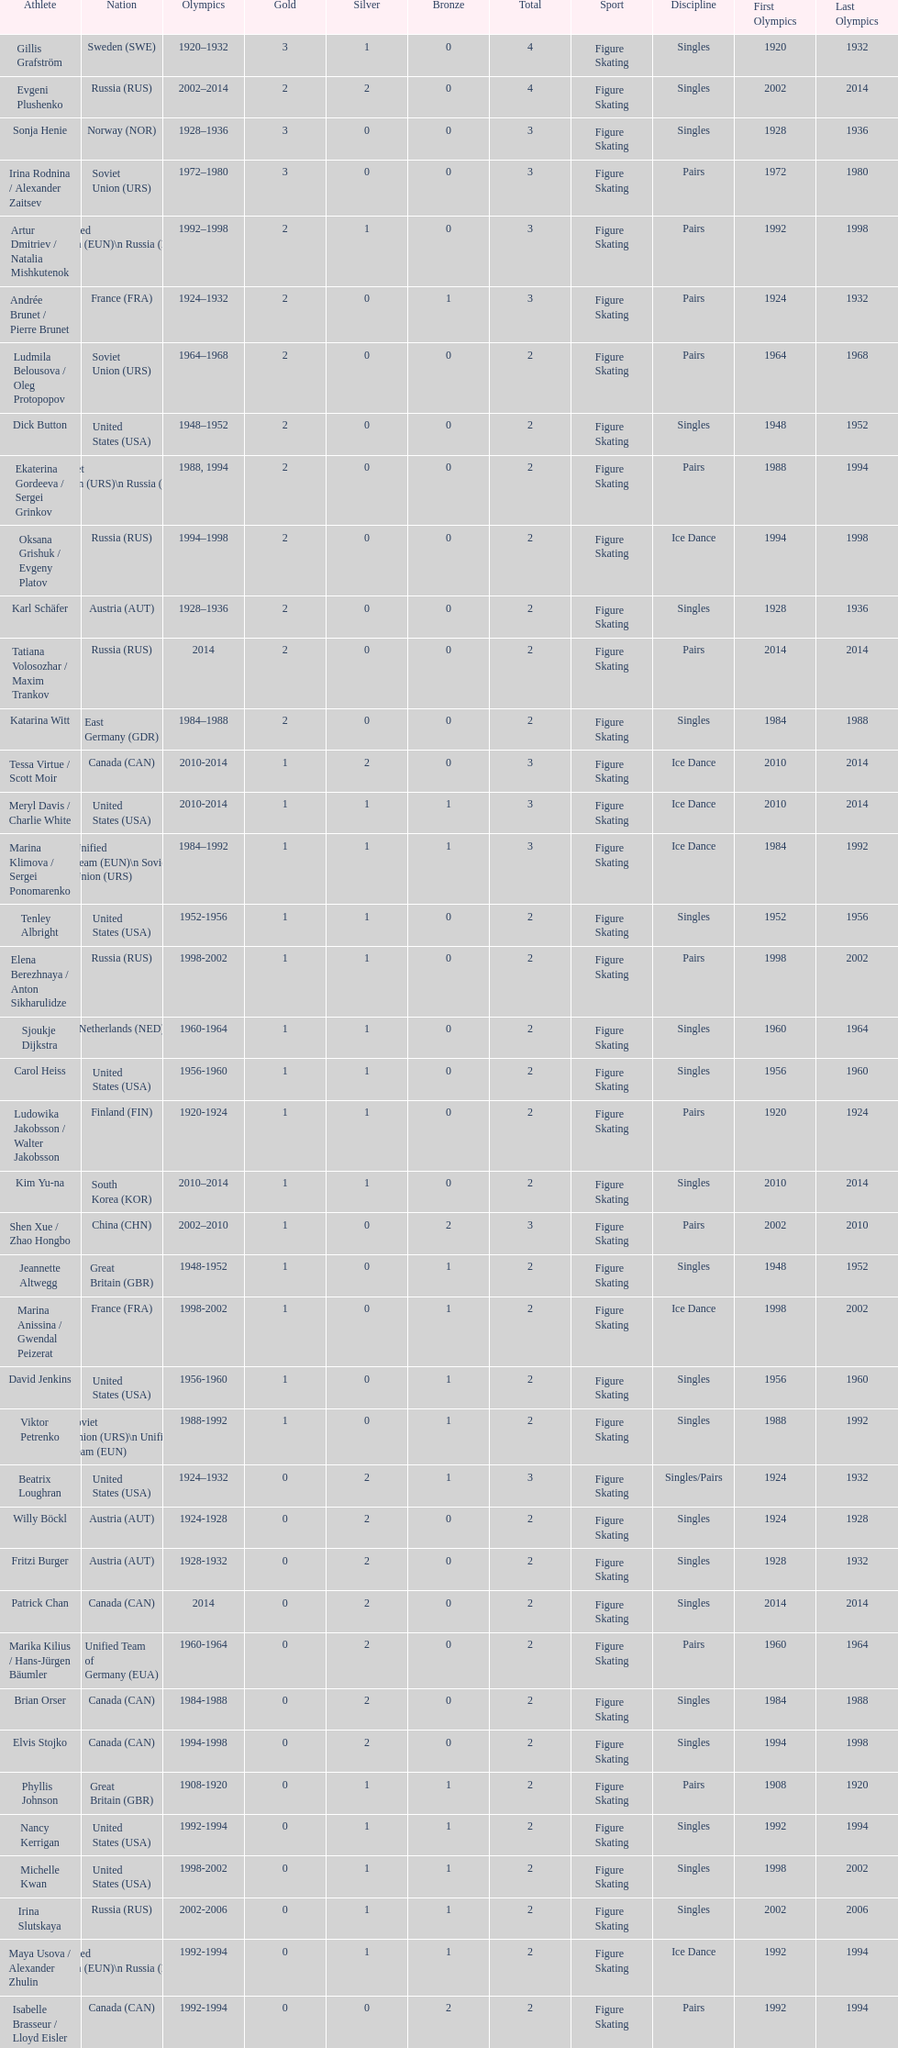Write the full table. {'header': ['Athlete', 'Nation', 'Olympics', 'Gold', 'Silver', 'Bronze', 'Total', 'Sport', 'Discipline', 'First Olympics', 'Last Olympics'], 'rows': [['Gillis Grafström', 'Sweden\xa0(SWE)', '1920–1932', '3', '1', '0', '4', 'Figure Skating', 'Singles', '1920', '1932'], ['Evgeni Plushenko', 'Russia\xa0(RUS)', '2002–2014', '2', '2', '0', '4', 'Figure Skating', 'Singles', '2002', '2014'], ['Sonja Henie', 'Norway\xa0(NOR)', '1928–1936', '3', '0', '0', '3', 'Figure Skating', 'Singles', '1928', '1936'], ['Irina Rodnina / Alexander Zaitsev', 'Soviet Union\xa0(URS)', '1972–1980', '3', '0', '0', '3', 'Figure Skating', 'Pairs', '1972', '1980'], ['Artur Dmitriev / Natalia Mishkutenok', 'Unified Team\xa0(EUN)\\n\xa0Russia\xa0(RUS)', '1992–1998', '2', '1', '0', '3', 'Figure Skating', 'Pairs', '1992', '1998'], ['Andrée Brunet / Pierre Brunet', 'France\xa0(FRA)', '1924–1932', '2', '0', '1', '3', 'Figure Skating', 'Pairs', '1924', '1932'], ['Ludmila Belousova / Oleg Protopopov', 'Soviet Union\xa0(URS)', '1964–1968', '2', '0', '0', '2', 'Figure Skating', 'Pairs', '1964', '1968'], ['Dick Button', 'United States\xa0(USA)', '1948–1952', '2', '0', '0', '2', 'Figure Skating', 'Singles', '1948', '1952'], ['Ekaterina Gordeeva / Sergei Grinkov', 'Soviet Union\xa0(URS)\\n\xa0Russia\xa0(RUS)', '1988, 1994', '2', '0', '0', '2', 'Figure Skating', 'Pairs', '1988', '1994'], ['Oksana Grishuk / Evgeny Platov', 'Russia\xa0(RUS)', '1994–1998', '2', '0', '0', '2', 'Figure Skating', 'Ice Dance', '1994', '1998'], ['Karl Schäfer', 'Austria\xa0(AUT)', '1928–1936', '2', '0', '0', '2', 'Figure Skating', 'Singles', '1928', '1936'], ['Tatiana Volosozhar / Maxim Trankov', 'Russia\xa0(RUS)', '2014', '2', '0', '0', '2', 'Figure Skating', 'Pairs', '2014', '2014'], ['Katarina Witt', 'East Germany\xa0(GDR)', '1984–1988', '2', '0', '0', '2', 'Figure Skating', 'Singles', '1984', '1988'], ['Tessa Virtue / Scott Moir', 'Canada\xa0(CAN)', '2010-2014', '1', '2', '0', '3', 'Figure Skating', 'Ice Dance', '2010', '2014'], ['Meryl Davis / Charlie White', 'United States\xa0(USA)', '2010-2014', '1', '1', '1', '3', 'Figure Skating', 'Ice Dance', '2010', '2014'], ['Marina Klimova / Sergei Ponomarenko', 'Unified Team\xa0(EUN)\\n\xa0Soviet Union\xa0(URS)', '1984–1992', '1', '1', '1', '3', 'Figure Skating', 'Ice Dance', '1984', '1992'], ['Tenley Albright', 'United States\xa0(USA)', '1952-1956', '1', '1', '0', '2', 'Figure Skating', 'Singles', '1952', '1956'], ['Elena Berezhnaya / Anton Sikharulidze', 'Russia\xa0(RUS)', '1998-2002', '1', '1', '0', '2', 'Figure Skating', 'Pairs', '1998', '2002'], ['Sjoukje Dijkstra', 'Netherlands\xa0(NED)', '1960-1964', '1', '1', '0', '2', 'Figure Skating', 'Singles', '1960', '1964'], ['Carol Heiss', 'United States\xa0(USA)', '1956-1960', '1', '1', '0', '2', 'Figure Skating', 'Singles', '1956', '1960'], ['Ludowika Jakobsson / Walter Jakobsson', 'Finland\xa0(FIN)', '1920-1924', '1', '1', '0', '2', 'Figure Skating', 'Pairs', '1920', '1924'], ['Kim Yu-na', 'South Korea\xa0(KOR)', '2010–2014', '1', '1', '0', '2', 'Figure Skating', 'Singles', '2010', '2014'], ['Shen Xue / Zhao Hongbo', 'China\xa0(CHN)', '2002–2010', '1', '0', '2', '3', 'Figure Skating', 'Pairs', '2002', '2010'], ['Jeannette Altwegg', 'Great Britain\xa0(GBR)', '1948-1952', '1', '0', '1', '2', 'Figure Skating', 'Singles', '1948', '1952'], ['Marina Anissina / Gwendal Peizerat', 'France\xa0(FRA)', '1998-2002', '1', '0', '1', '2', 'Figure Skating', 'Ice Dance', '1998', '2002'], ['David Jenkins', 'United States\xa0(USA)', '1956-1960', '1', '0', '1', '2', 'Figure Skating', 'Singles', '1956', '1960'], ['Viktor Petrenko', 'Soviet Union\xa0(URS)\\n\xa0Unified Team\xa0(EUN)', '1988-1992', '1', '0', '1', '2', 'Figure Skating', 'Singles', '1988', '1992'], ['Beatrix Loughran', 'United States\xa0(USA)', '1924–1932', '0', '2', '1', '3', 'Figure Skating', 'Singles/Pairs', '1924', '1932'], ['Willy Böckl', 'Austria\xa0(AUT)', '1924-1928', '0', '2', '0', '2', 'Figure Skating', 'Singles', '1924', '1928'], ['Fritzi Burger', 'Austria\xa0(AUT)', '1928-1932', '0', '2', '0', '2', 'Figure Skating', 'Singles', '1928', '1932'], ['Patrick Chan', 'Canada\xa0(CAN)', '2014', '0', '2', '0', '2', 'Figure Skating', 'Singles', '2014', '2014'], ['Marika Kilius / Hans-Jürgen Bäumler', 'Unified Team of Germany\xa0(EUA)', '1960-1964', '0', '2', '0', '2', 'Figure Skating', 'Pairs', '1960', '1964'], ['Brian Orser', 'Canada\xa0(CAN)', '1984-1988', '0', '2', '0', '2', 'Figure Skating', 'Singles', '1984', '1988'], ['Elvis Stojko', 'Canada\xa0(CAN)', '1994-1998', '0', '2', '0', '2', 'Figure Skating', 'Singles', '1994', '1998'], ['Phyllis Johnson', 'Great Britain\xa0(GBR)', '1908-1920', '0', '1', '1', '2', 'Figure Skating', 'Pairs', '1908', '1920'], ['Nancy Kerrigan', 'United States\xa0(USA)', '1992-1994', '0', '1', '1', '2', 'Figure Skating', 'Singles', '1992', '1994'], ['Michelle Kwan', 'United States\xa0(USA)', '1998-2002', '0', '1', '1', '2', 'Figure Skating', 'Singles', '1998', '2002'], ['Irina Slutskaya', 'Russia\xa0(RUS)', '2002-2006', '0', '1', '1', '2', 'Figure Skating', 'Singles', '2002', '2006'], ['Maya Usova / Alexander Zhulin', 'Unified Team\xa0(EUN)\\n\xa0Russia\xa0(RUS)', '1992-1994', '0', '1', '1', '2', 'Figure Skating', 'Ice Dance', '1992', '1994'], ['Isabelle Brasseur / Lloyd Eisler', 'Canada\xa0(CAN)', '1992-1994', '0', '0', '2', '2', 'Figure Skating', 'Pairs', '1992', '1994'], ['Philippe Candeloro', 'France\xa0(FRA)', '1994-1998', '0', '0', '2', '2', 'Figure Skating', 'Singles', '1994', '1998'], ['Manuela Groß / Uwe Kagelmann', 'East Germany\xa0(GDR)', '1972-1976', '0', '0', '2', '2', 'Figure Skating', 'Pairs', '1972', '1976'], ['Chen Lu', 'China\xa0(CHN)', '1994-1998', '0', '0', '2', '2', 'Figure Skating', 'Singles', '1994', '1998'], ['Marianna Nagy / László Nagy', 'Hungary\xa0(HUN)', '1952-1956', '0', '0', '2', '2', 'Figure Skating', 'Pairs', '1952', '1956'], ['Patrick Péra', 'France\xa0(FRA)', '1968-1972', '0', '0', '2', '2', 'Figure Skating', 'Singles', '1968', '1972'], ['Emília Rotter / László Szollás', 'Hungary\xa0(HUN)', '1932-1936', '0', '0', '2', '2', 'Figure Skating', 'Pairs', '1932', '1936'], ['Aliona Savchenko / Robin Szolkowy', 'Germany\xa0(GER)', '2010-2014', '0', '0', '2', '2', 'Figure Skating', 'Pairs', '2010', '2014']]} How many silver medals has evgeni plushenko won? 2. 